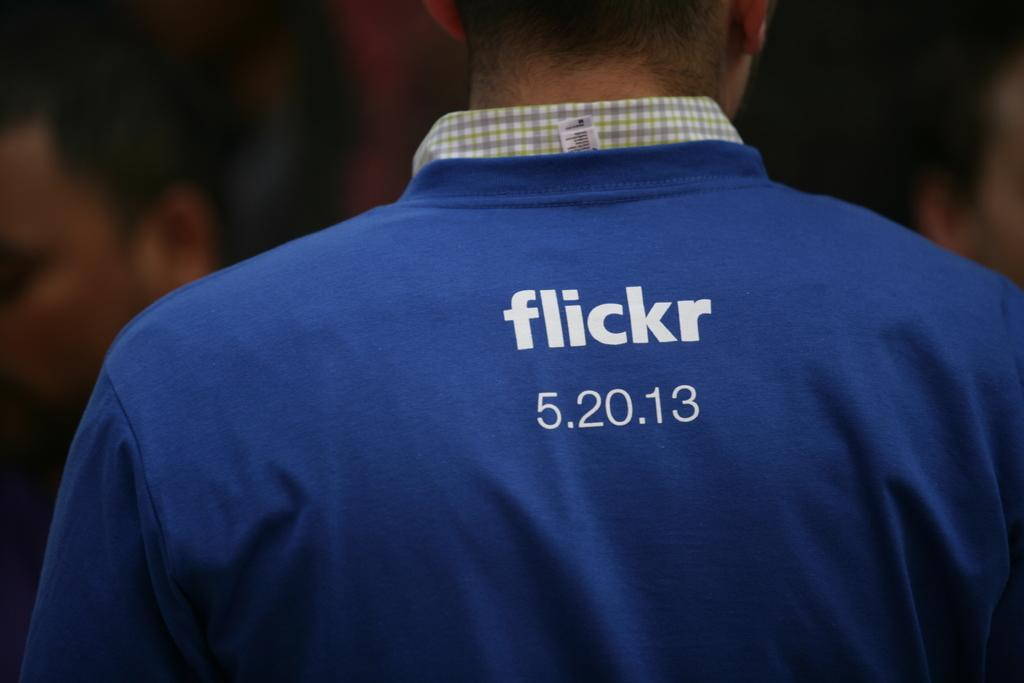<image>
Create a compact narrative representing the image presented. The flickr logo can be seen on the back of someone's shirt. 